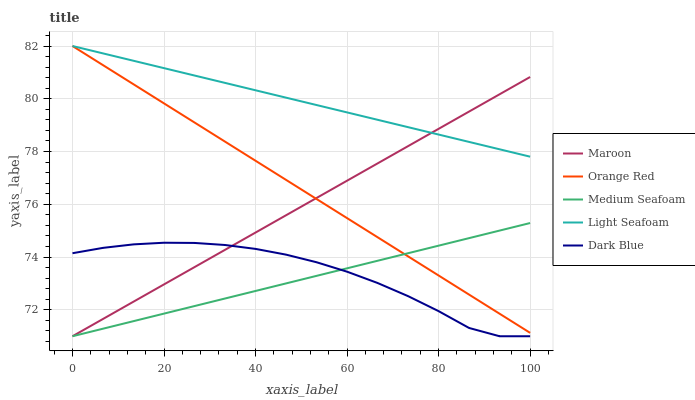Does Medium Seafoam have the minimum area under the curve?
Answer yes or no. Yes. Does Light Seafoam have the maximum area under the curve?
Answer yes or no. Yes. Does Orange Red have the minimum area under the curve?
Answer yes or no. No. Does Orange Red have the maximum area under the curve?
Answer yes or no. No. Is Light Seafoam the smoothest?
Answer yes or no. Yes. Is Dark Blue the roughest?
Answer yes or no. Yes. Is Orange Red the smoothest?
Answer yes or no. No. Is Orange Red the roughest?
Answer yes or no. No. Does Dark Blue have the lowest value?
Answer yes or no. Yes. Does Orange Red have the lowest value?
Answer yes or no. No. Does Orange Red have the highest value?
Answer yes or no. Yes. Does Maroon have the highest value?
Answer yes or no. No. Is Dark Blue less than Orange Red?
Answer yes or no. Yes. Is Orange Red greater than Dark Blue?
Answer yes or no. Yes. Does Light Seafoam intersect Maroon?
Answer yes or no. Yes. Is Light Seafoam less than Maroon?
Answer yes or no. No. Is Light Seafoam greater than Maroon?
Answer yes or no. No. Does Dark Blue intersect Orange Red?
Answer yes or no. No. 